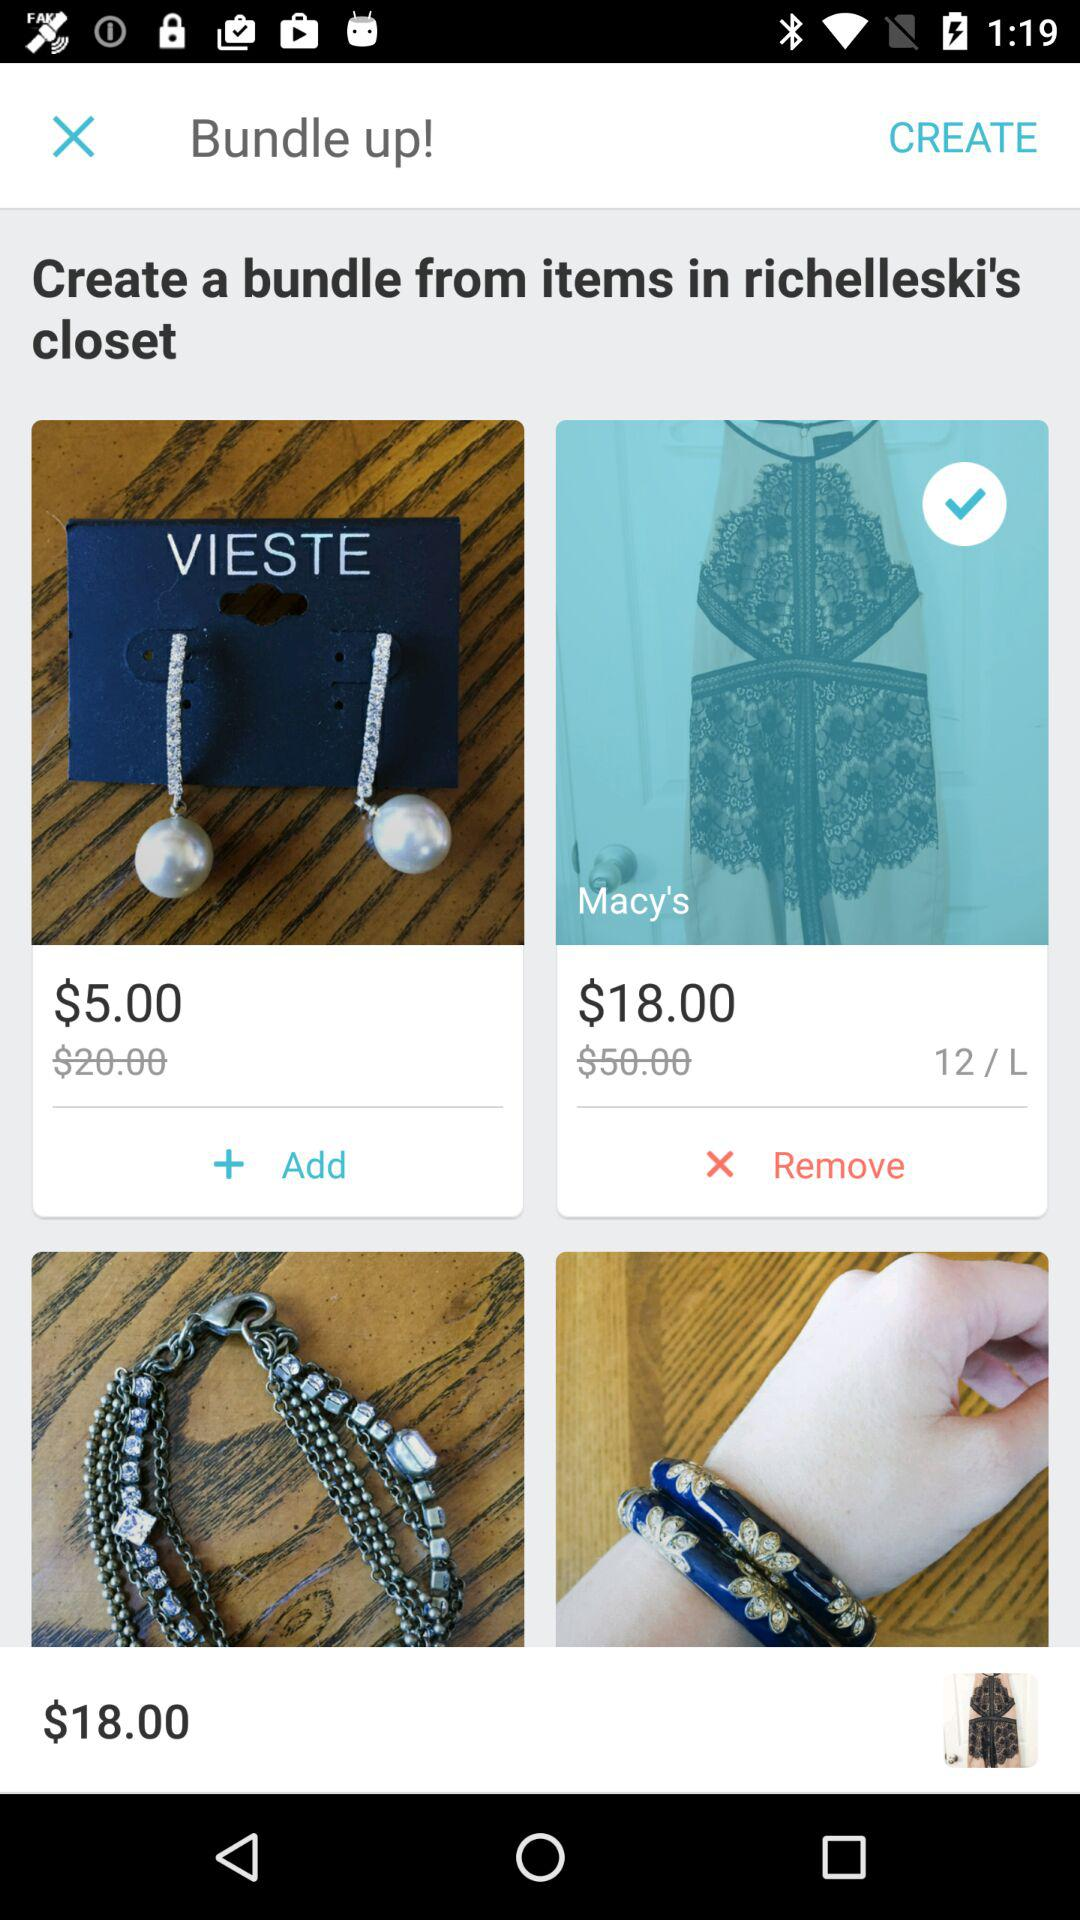What is the mentioned size of "Macy's"? The mentioned size is 12/L. 